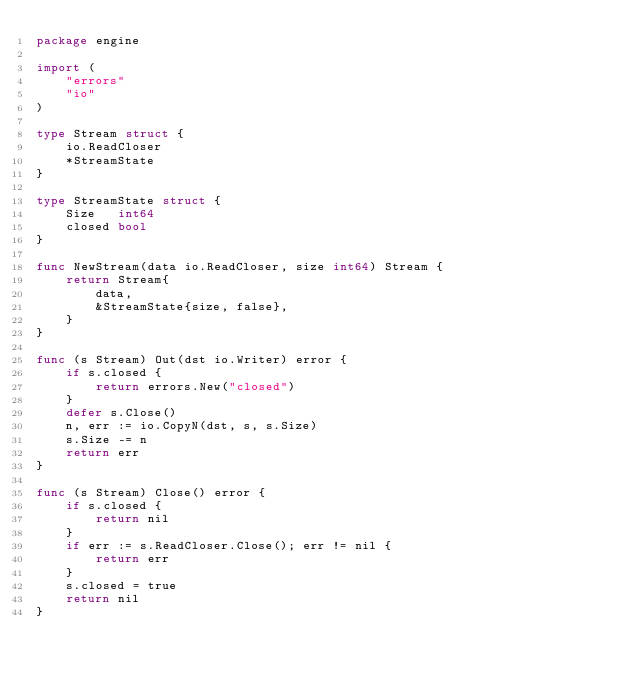<code> <loc_0><loc_0><loc_500><loc_500><_Go_>package engine

import (
	"errors"
	"io"
)

type Stream struct {
	io.ReadCloser
	*StreamState
}

type StreamState struct {
	Size   int64
	closed bool
}

func NewStream(data io.ReadCloser, size int64) Stream {
	return Stream{
		data,
		&StreamState{size, false},
	}
}

func (s Stream) Out(dst io.Writer) error {
	if s.closed {
		return errors.New("closed")
	}
	defer s.Close()
	n, err := io.CopyN(dst, s, s.Size)
	s.Size -= n
	return err
}

func (s Stream) Close() error {
	if s.closed {
		return nil
	}
	if err := s.ReadCloser.Close(); err != nil {
		return err
	}
	s.closed = true
	return nil
}
</code> 